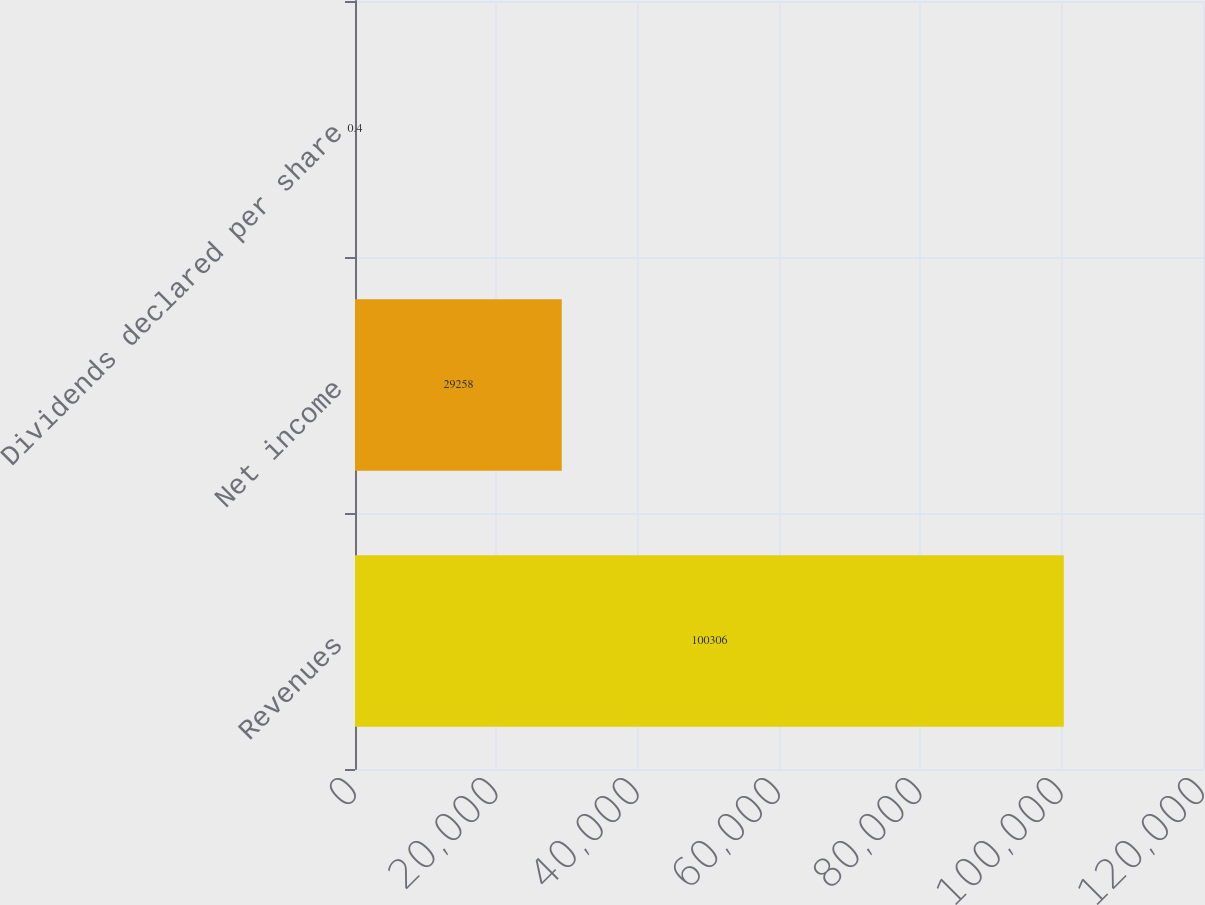Convert chart to OTSL. <chart><loc_0><loc_0><loc_500><loc_500><bar_chart><fcel>Revenues<fcel>Net income<fcel>Dividends declared per share<nl><fcel>100306<fcel>29258<fcel>0.4<nl></chart> 